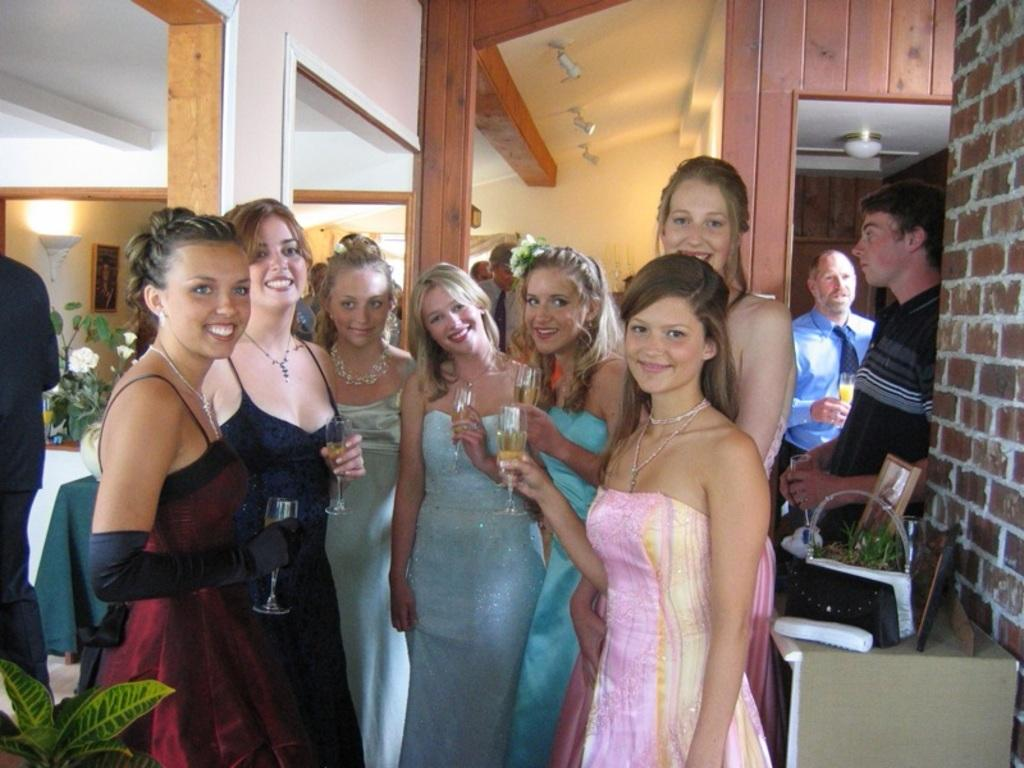How many people are in the image? There is a group of people in the image. What are the people holding in the image? The people are standing and holding glasses. What architectural features can be seen in the image? There are pillars visible in the image. What type of background is present in the image? There is a wall in the image. What type of vegetation is present in the image? There are plants in the image. What type of lighting is present in the image? There is light in the image. What objects can be seen on a table in the image? There are objects on a table in the image. How is the frame attached to the wall in the image? The frame is attached to the wall. What type of authority is present in the image? There is no specific authority figure present in the image. What type of air is visible in the image? The image does not show any specific type of air; it simply shows a well-lit environment. 